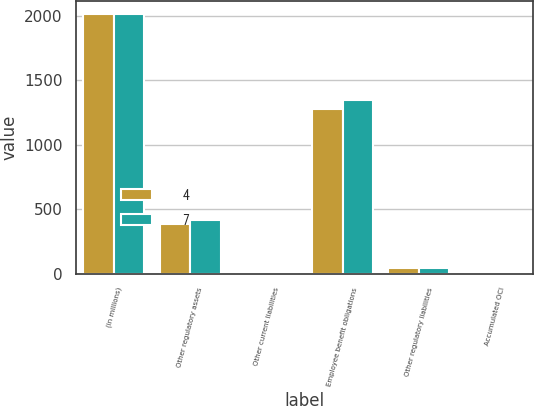Convert chart to OTSL. <chart><loc_0><loc_0><loc_500><loc_500><stacked_bar_chart><ecel><fcel>(in millions)<fcel>Other regulatory assets<fcel>Other current liabilities<fcel>Employee benefit obligations<fcel>Other regulatory liabilities<fcel>Accumulated OCI<nl><fcel>4<fcel>2017<fcel>382<fcel>5<fcel>1281<fcel>41<fcel>4<nl><fcel>7<fcel>2016<fcel>419<fcel>4<fcel>1349<fcel>41<fcel>7<nl></chart> 